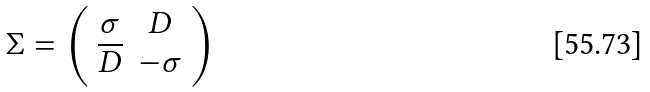<formula> <loc_0><loc_0><loc_500><loc_500>\Sigma = \left ( \begin{array} { c c } { \sigma } & { D } \\ { { \overline { D } } } & { - \sigma } \end{array} \right )</formula> 